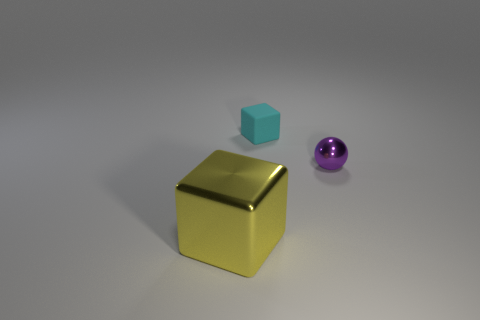Add 2 tiny brown rubber spheres. How many objects exist? 5 Subtract all balls. How many objects are left? 2 Subtract all metallic blocks. Subtract all big green cylinders. How many objects are left? 2 Add 2 balls. How many balls are left? 3 Add 1 large brown objects. How many large brown objects exist? 1 Subtract 0 gray spheres. How many objects are left? 3 